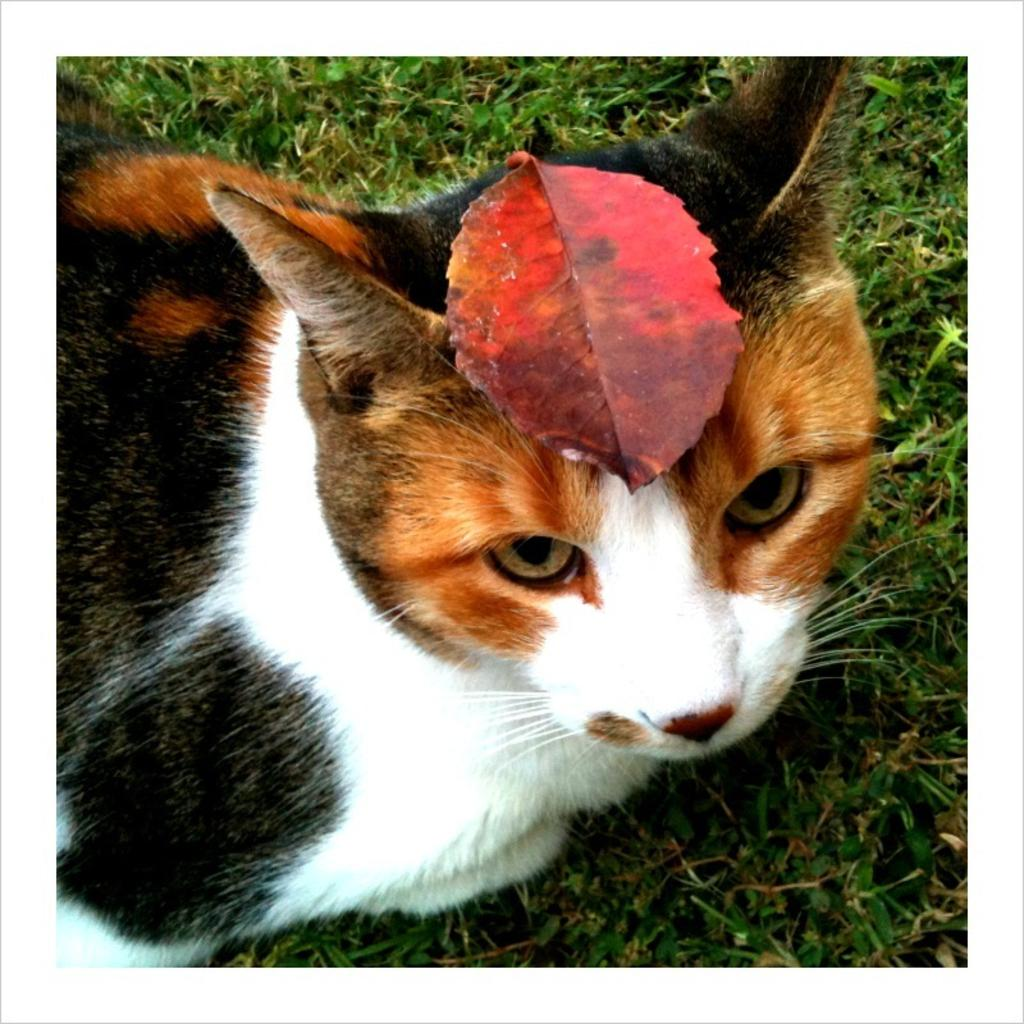What type of animal is in the image? There is a cat in the image. What is on the ground in the image? There is grass on the ground in the image. What is on the cat's head? There is a leaf on the cat's head. What type of oatmeal is being served at the feast in the image? There is no feast or oatmeal present in the image; it features a cat with a leaf on its head and grass on the ground. 